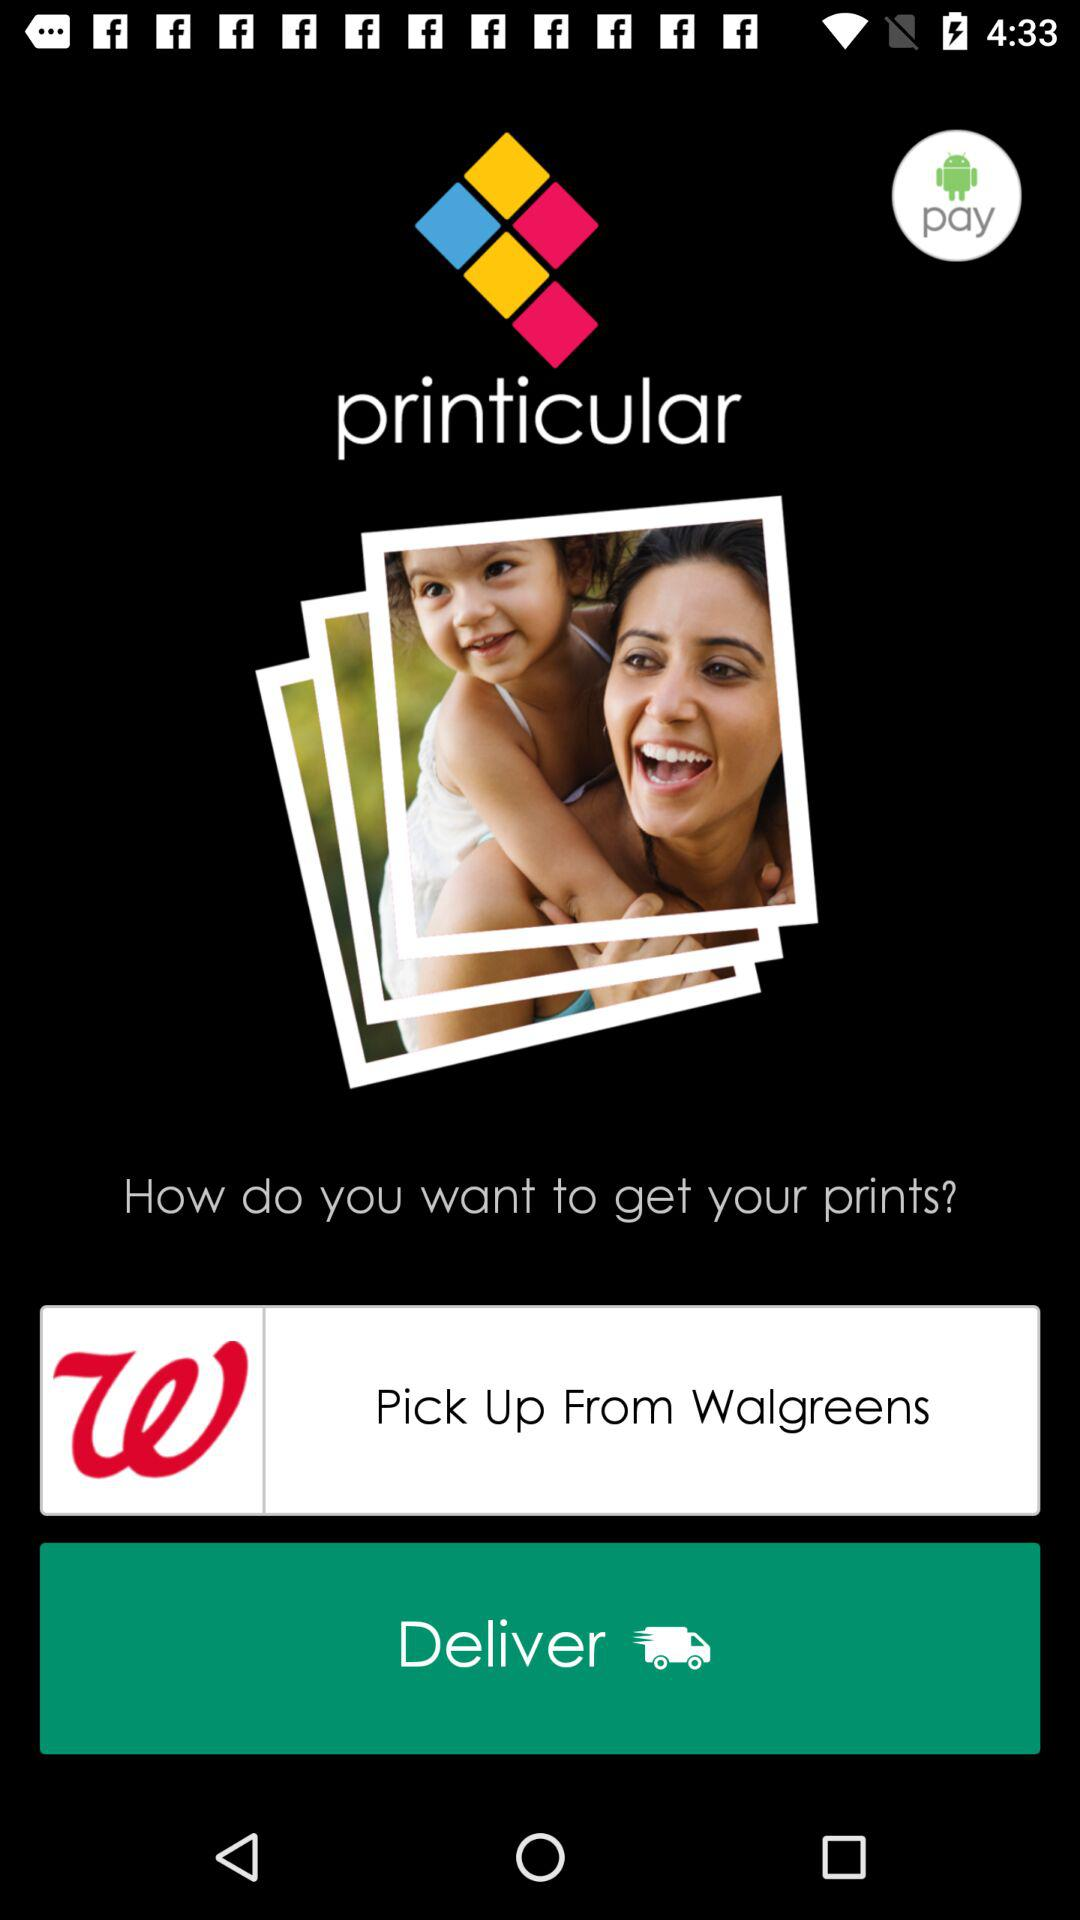How many options are there to get my prints?
Answer the question using a single word or phrase. 2 